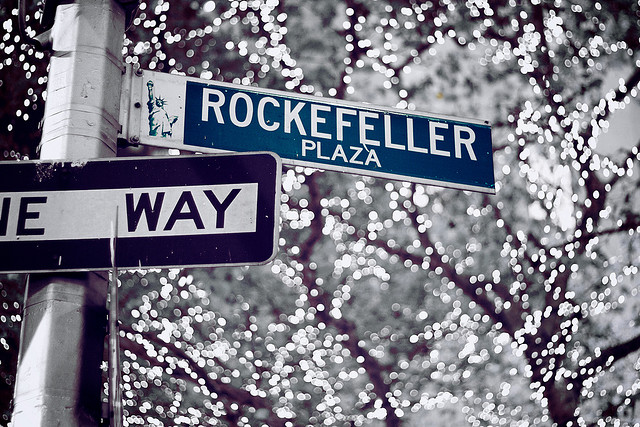Identify the text displayed in this image. ROCKEFELLER PLAZA PLAZA WAY IE 